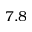Convert formula to latex. <formula><loc_0><loc_0><loc_500><loc_500>7 . 8</formula> 